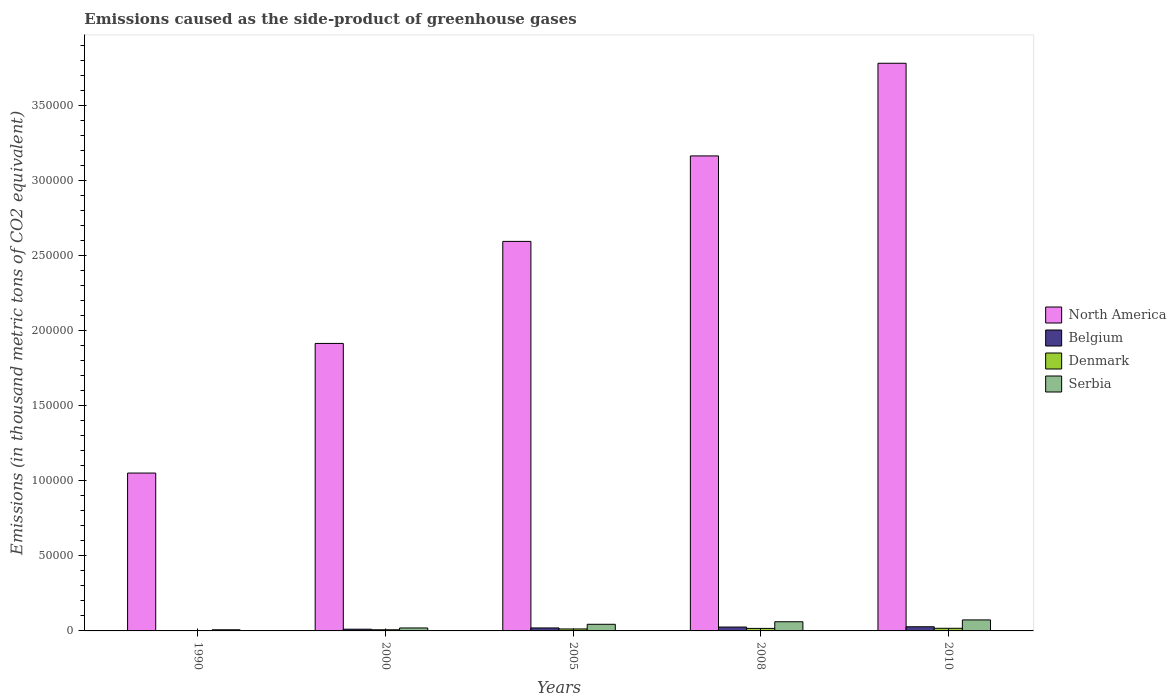How many different coloured bars are there?
Your answer should be very brief. 4. How many bars are there on the 1st tick from the left?
Keep it short and to the point. 4. How many bars are there on the 4th tick from the right?
Make the answer very short. 4. What is the emissions caused as the side-product of greenhouse gases in North America in 2005?
Make the answer very short. 2.60e+05. Across all years, what is the maximum emissions caused as the side-product of greenhouse gases in North America?
Make the answer very short. 3.78e+05. Across all years, what is the minimum emissions caused as the side-product of greenhouse gases in Denmark?
Your response must be concise. 88.4. In which year was the emissions caused as the side-product of greenhouse gases in Serbia maximum?
Provide a succinct answer. 2010. What is the total emissions caused as the side-product of greenhouse gases in Denmark in the graph?
Ensure brevity in your answer.  5592.4. What is the difference between the emissions caused as the side-product of greenhouse gases in Serbia in 1990 and that in 2000?
Offer a terse response. -1205.7. What is the difference between the emissions caused as the side-product of greenhouse gases in Belgium in 2000 and the emissions caused as the side-product of greenhouse gases in Denmark in 2010?
Provide a short and direct response. -595.4. What is the average emissions caused as the side-product of greenhouse gases in Belgium per year?
Ensure brevity in your answer.  1726.34. In the year 2008, what is the difference between the emissions caused as the side-product of greenhouse gases in North America and emissions caused as the side-product of greenhouse gases in Serbia?
Keep it short and to the point. 3.10e+05. In how many years, is the emissions caused as the side-product of greenhouse gases in Belgium greater than 380000 thousand metric tons?
Provide a succinct answer. 0. What is the ratio of the emissions caused as the side-product of greenhouse gases in Serbia in 2005 to that in 2008?
Give a very brief answer. 0.72. Is the emissions caused as the side-product of greenhouse gases in North America in 1990 less than that in 2010?
Provide a short and direct response. Yes. What is the difference between the highest and the second highest emissions caused as the side-product of greenhouse gases in North America?
Keep it short and to the point. 6.17e+04. What is the difference between the highest and the lowest emissions caused as the side-product of greenhouse gases in Denmark?
Provide a short and direct response. 1661.6. In how many years, is the emissions caused as the side-product of greenhouse gases in Serbia greater than the average emissions caused as the side-product of greenhouse gases in Serbia taken over all years?
Ensure brevity in your answer.  3. Is it the case that in every year, the sum of the emissions caused as the side-product of greenhouse gases in North America and emissions caused as the side-product of greenhouse gases in Denmark is greater than the sum of emissions caused as the side-product of greenhouse gases in Serbia and emissions caused as the side-product of greenhouse gases in Belgium?
Ensure brevity in your answer.  Yes. Is it the case that in every year, the sum of the emissions caused as the side-product of greenhouse gases in Belgium and emissions caused as the side-product of greenhouse gases in Serbia is greater than the emissions caused as the side-product of greenhouse gases in Denmark?
Ensure brevity in your answer.  Yes. Are the values on the major ticks of Y-axis written in scientific E-notation?
Your answer should be very brief. No. Where does the legend appear in the graph?
Offer a terse response. Center right. How many legend labels are there?
Your response must be concise. 4. How are the legend labels stacked?
Provide a short and direct response. Vertical. What is the title of the graph?
Offer a terse response. Emissions caused as the side-product of greenhouse gases. What is the label or title of the X-axis?
Offer a very short reply. Years. What is the label or title of the Y-axis?
Ensure brevity in your answer.  Emissions (in thousand metric tons of CO2 equivalent). What is the Emissions (in thousand metric tons of CO2 equivalent) in North America in 1990?
Provide a short and direct response. 1.05e+05. What is the Emissions (in thousand metric tons of CO2 equivalent) of Belgium in 1990?
Provide a succinct answer. 141.9. What is the Emissions (in thousand metric tons of CO2 equivalent) in Denmark in 1990?
Keep it short and to the point. 88.4. What is the Emissions (in thousand metric tons of CO2 equivalent) of Serbia in 1990?
Give a very brief answer. 762.4. What is the Emissions (in thousand metric tons of CO2 equivalent) of North America in 2000?
Offer a very short reply. 1.92e+05. What is the Emissions (in thousand metric tons of CO2 equivalent) in Belgium in 2000?
Provide a short and direct response. 1154.6. What is the Emissions (in thousand metric tons of CO2 equivalent) in Denmark in 2000?
Provide a short and direct response. 767. What is the Emissions (in thousand metric tons of CO2 equivalent) of Serbia in 2000?
Provide a succinct answer. 1968.1. What is the Emissions (in thousand metric tons of CO2 equivalent) of North America in 2005?
Offer a very short reply. 2.60e+05. What is the Emissions (in thousand metric tons of CO2 equivalent) in Belgium in 2005?
Give a very brief answer. 1981.2. What is the Emissions (in thousand metric tons of CO2 equivalent) in Denmark in 2005?
Give a very brief answer. 1302.5. What is the Emissions (in thousand metric tons of CO2 equivalent) in Serbia in 2005?
Your answer should be compact. 4422.8. What is the Emissions (in thousand metric tons of CO2 equivalent) of North America in 2008?
Your answer should be very brief. 3.17e+05. What is the Emissions (in thousand metric tons of CO2 equivalent) in Belgium in 2008?
Your answer should be very brief. 2578. What is the Emissions (in thousand metric tons of CO2 equivalent) of Denmark in 2008?
Offer a very short reply. 1684.5. What is the Emissions (in thousand metric tons of CO2 equivalent) in Serbia in 2008?
Provide a short and direct response. 6111.3. What is the Emissions (in thousand metric tons of CO2 equivalent) in North America in 2010?
Offer a very short reply. 3.78e+05. What is the Emissions (in thousand metric tons of CO2 equivalent) of Belgium in 2010?
Provide a succinct answer. 2776. What is the Emissions (in thousand metric tons of CO2 equivalent) of Denmark in 2010?
Offer a terse response. 1750. What is the Emissions (in thousand metric tons of CO2 equivalent) in Serbia in 2010?
Offer a very short reply. 7338. Across all years, what is the maximum Emissions (in thousand metric tons of CO2 equivalent) in North America?
Your answer should be very brief. 3.78e+05. Across all years, what is the maximum Emissions (in thousand metric tons of CO2 equivalent) in Belgium?
Offer a terse response. 2776. Across all years, what is the maximum Emissions (in thousand metric tons of CO2 equivalent) in Denmark?
Offer a terse response. 1750. Across all years, what is the maximum Emissions (in thousand metric tons of CO2 equivalent) in Serbia?
Your response must be concise. 7338. Across all years, what is the minimum Emissions (in thousand metric tons of CO2 equivalent) in North America?
Ensure brevity in your answer.  1.05e+05. Across all years, what is the minimum Emissions (in thousand metric tons of CO2 equivalent) of Belgium?
Give a very brief answer. 141.9. Across all years, what is the minimum Emissions (in thousand metric tons of CO2 equivalent) of Denmark?
Your answer should be compact. 88.4. Across all years, what is the minimum Emissions (in thousand metric tons of CO2 equivalent) of Serbia?
Keep it short and to the point. 762.4. What is the total Emissions (in thousand metric tons of CO2 equivalent) of North America in the graph?
Your answer should be compact. 1.25e+06. What is the total Emissions (in thousand metric tons of CO2 equivalent) of Belgium in the graph?
Your answer should be very brief. 8631.7. What is the total Emissions (in thousand metric tons of CO2 equivalent) in Denmark in the graph?
Give a very brief answer. 5592.4. What is the total Emissions (in thousand metric tons of CO2 equivalent) of Serbia in the graph?
Your response must be concise. 2.06e+04. What is the difference between the Emissions (in thousand metric tons of CO2 equivalent) in North America in 1990 and that in 2000?
Offer a terse response. -8.64e+04. What is the difference between the Emissions (in thousand metric tons of CO2 equivalent) of Belgium in 1990 and that in 2000?
Offer a terse response. -1012.7. What is the difference between the Emissions (in thousand metric tons of CO2 equivalent) in Denmark in 1990 and that in 2000?
Provide a succinct answer. -678.6. What is the difference between the Emissions (in thousand metric tons of CO2 equivalent) of Serbia in 1990 and that in 2000?
Provide a short and direct response. -1205.7. What is the difference between the Emissions (in thousand metric tons of CO2 equivalent) in North America in 1990 and that in 2005?
Keep it short and to the point. -1.54e+05. What is the difference between the Emissions (in thousand metric tons of CO2 equivalent) of Belgium in 1990 and that in 2005?
Provide a short and direct response. -1839.3. What is the difference between the Emissions (in thousand metric tons of CO2 equivalent) in Denmark in 1990 and that in 2005?
Provide a short and direct response. -1214.1. What is the difference between the Emissions (in thousand metric tons of CO2 equivalent) in Serbia in 1990 and that in 2005?
Your answer should be very brief. -3660.4. What is the difference between the Emissions (in thousand metric tons of CO2 equivalent) in North America in 1990 and that in 2008?
Offer a terse response. -2.11e+05. What is the difference between the Emissions (in thousand metric tons of CO2 equivalent) in Belgium in 1990 and that in 2008?
Keep it short and to the point. -2436.1. What is the difference between the Emissions (in thousand metric tons of CO2 equivalent) of Denmark in 1990 and that in 2008?
Offer a terse response. -1596.1. What is the difference between the Emissions (in thousand metric tons of CO2 equivalent) in Serbia in 1990 and that in 2008?
Ensure brevity in your answer.  -5348.9. What is the difference between the Emissions (in thousand metric tons of CO2 equivalent) in North America in 1990 and that in 2010?
Make the answer very short. -2.73e+05. What is the difference between the Emissions (in thousand metric tons of CO2 equivalent) in Belgium in 1990 and that in 2010?
Your response must be concise. -2634.1. What is the difference between the Emissions (in thousand metric tons of CO2 equivalent) of Denmark in 1990 and that in 2010?
Offer a terse response. -1661.6. What is the difference between the Emissions (in thousand metric tons of CO2 equivalent) in Serbia in 1990 and that in 2010?
Provide a short and direct response. -6575.6. What is the difference between the Emissions (in thousand metric tons of CO2 equivalent) of North America in 2000 and that in 2005?
Your answer should be very brief. -6.80e+04. What is the difference between the Emissions (in thousand metric tons of CO2 equivalent) of Belgium in 2000 and that in 2005?
Offer a terse response. -826.6. What is the difference between the Emissions (in thousand metric tons of CO2 equivalent) in Denmark in 2000 and that in 2005?
Offer a very short reply. -535.5. What is the difference between the Emissions (in thousand metric tons of CO2 equivalent) in Serbia in 2000 and that in 2005?
Your answer should be very brief. -2454.7. What is the difference between the Emissions (in thousand metric tons of CO2 equivalent) in North America in 2000 and that in 2008?
Offer a terse response. -1.25e+05. What is the difference between the Emissions (in thousand metric tons of CO2 equivalent) of Belgium in 2000 and that in 2008?
Your response must be concise. -1423.4. What is the difference between the Emissions (in thousand metric tons of CO2 equivalent) in Denmark in 2000 and that in 2008?
Your answer should be very brief. -917.5. What is the difference between the Emissions (in thousand metric tons of CO2 equivalent) of Serbia in 2000 and that in 2008?
Give a very brief answer. -4143.2. What is the difference between the Emissions (in thousand metric tons of CO2 equivalent) of North America in 2000 and that in 2010?
Offer a terse response. -1.87e+05. What is the difference between the Emissions (in thousand metric tons of CO2 equivalent) of Belgium in 2000 and that in 2010?
Give a very brief answer. -1621.4. What is the difference between the Emissions (in thousand metric tons of CO2 equivalent) of Denmark in 2000 and that in 2010?
Offer a terse response. -983. What is the difference between the Emissions (in thousand metric tons of CO2 equivalent) of Serbia in 2000 and that in 2010?
Provide a succinct answer. -5369.9. What is the difference between the Emissions (in thousand metric tons of CO2 equivalent) in North America in 2005 and that in 2008?
Your answer should be compact. -5.70e+04. What is the difference between the Emissions (in thousand metric tons of CO2 equivalent) in Belgium in 2005 and that in 2008?
Keep it short and to the point. -596.8. What is the difference between the Emissions (in thousand metric tons of CO2 equivalent) in Denmark in 2005 and that in 2008?
Offer a very short reply. -382. What is the difference between the Emissions (in thousand metric tons of CO2 equivalent) of Serbia in 2005 and that in 2008?
Give a very brief answer. -1688.5. What is the difference between the Emissions (in thousand metric tons of CO2 equivalent) in North America in 2005 and that in 2010?
Provide a short and direct response. -1.19e+05. What is the difference between the Emissions (in thousand metric tons of CO2 equivalent) of Belgium in 2005 and that in 2010?
Your answer should be very brief. -794.8. What is the difference between the Emissions (in thousand metric tons of CO2 equivalent) in Denmark in 2005 and that in 2010?
Your response must be concise. -447.5. What is the difference between the Emissions (in thousand metric tons of CO2 equivalent) in Serbia in 2005 and that in 2010?
Provide a short and direct response. -2915.2. What is the difference between the Emissions (in thousand metric tons of CO2 equivalent) of North America in 2008 and that in 2010?
Make the answer very short. -6.17e+04. What is the difference between the Emissions (in thousand metric tons of CO2 equivalent) of Belgium in 2008 and that in 2010?
Your answer should be very brief. -198. What is the difference between the Emissions (in thousand metric tons of CO2 equivalent) of Denmark in 2008 and that in 2010?
Keep it short and to the point. -65.5. What is the difference between the Emissions (in thousand metric tons of CO2 equivalent) of Serbia in 2008 and that in 2010?
Your response must be concise. -1226.7. What is the difference between the Emissions (in thousand metric tons of CO2 equivalent) of North America in 1990 and the Emissions (in thousand metric tons of CO2 equivalent) of Belgium in 2000?
Keep it short and to the point. 1.04e+05. What is the difference between the Emissions (in thousand metric tons of CO2 equivalent) in North America in 1990 and the Emissions (in thousand metric tons of CO2 equivalent) in Denmark in 2000?
Your answer should be compact. 1.04e+05. What is the difference between the Emissions (in thousand metric tons of CO2 equivalent) of North America in 1990 and the Emissions (in thousand metric tons of CO2 equivalent) of Serbia in 2000?
Provide a short and direct response. 1.03e+05. What is the difference between the Emissions (in thousand metric tons of CO2 equivalent) of Belgium in 1990 and the Emissions (in thousand metric tons of CO2 equivalent) of Denmark in 2000?
Ensure brevity in your answer.  -625.1. What is the difference between the Emissions (in thousand metric tons of CO2 equivalent) of Belgium in 1990 and the Emissions (in thousand metric tons of CO2 equivalent) of Serbia in 2000?
Make the answer very short. -1826.2. What is the difference between the Emissions (in thousand metric tons of CO2 equivalent) in Denmark in 1990 and the Emissions (in thousand metric tons of CO2 equivalent) in Serbia in 2000?
Provide a short and direct response. -1879.7. What is the difference between the Emissions (in thousand metric tons of CO2 equivalent) in North America in 1990 and the Emissions (in thousand metric tons of CO2 equivalent) in Belgium in 2005?
Offer a terse response. 1.03e+05. What is the difference between the Emissions (in thousand metric tons of CO2 equivalent) of North America in 1990 and the Emissions (in thousand metric tons of CO2 equivalent) of Denmark in 2005?
Offer a terse response. 1.04e+05. What is the difference between the Emissions (in thousand metric tons of CO2 equivalent) in North America in 1990 and the Emissions (in thousand metric tons of CO2 equivalent) in Serbia in 2005?
Make the answer very short. 1.01e+05. What is the difference between the Emissions (in thousand metric tons of CO2 equivalent) in Belgium in 1990 and the Emissions (in thousand metric tons of CO2 equivalent) in Denmark in 2005?
Provide a succinct answer. -1160.6. What is the difference between the Emissions (in thousand metric tons of CO2 equivalent) in Belgium in 1990 and the Emissions (in thousand metric tons of CO2 equivalent) in Serbia in 2005?
Provide a short and direct response. -4280.9. What is the difference between the Emissions (in thousand metric tons of CO2 equivalent) in Denmark in 1990 and the Emissions (in thousand metric tons of CO2 equivalent) in Serbia in 2005?
Offer a terse response. -4334.4. What is the difference between the Emissions (in thousand metric tons of CO2 equivalent) in North America in 1990 and the Emissions (in thousand metric tons of CO2 equivalent) in Belgium in 2008?
Your answer should be very brief. 1.03e+05. What is the difference between the Emissions (in thousand metric tons of CO2 equivalent) of North America in 1990 and the Emissions (in thousand metric tons of CO2 equivalent) of Denmark in 2008?
Provide a succinct answer. 1.04e+05. What is the difference between the Emissions (in thousand metric tons of CO2 equivalent) in North America in 1990 and the Emissions (in thousand metric tons of CO2 equivalent) in Serbia in 2008?
Ensure brevity in your answer.  9.91e+04. What is the difference between the Emissions (in thousand metric tons of CO2 equivalent) of Belgium in 1990 and the Emissions (in thousand metric tons of CO2 equivalent) of Denmark in 2008?
Offer a terse response. -1542.6. What is the difference between the Emissions (in thousand metric tons of CO2 equivalent) in Belgium in 1990 and the Emissions (in thousand metric tons of CO2 equivalent) in Serbia in 2008?
Make the answer very short. -5969.4. What is the difference between the Emissions (in thousand metric tons of CO2 equivalent) of Denmark in 1990 and the Emissions (in thousand metric tons of CO2 equivalent) of Serbia in 2008?
Provide a succinct answer. -6022.9. What is the difference between the Emissions (in thousand metric tons of CO2 equivalent) of North America in 1990 and the Emissions (in thousand metric tons of CO2 equivalent) of Belgium in 2010?
Make the answer very short. 1.02e+05. What is the difference between the Emissions (in thousand metric tons of CO2 equivalent) in North America in 1990 and the Emissions (in thousand metric tons of CO2 equivalent) in Denmark in 2010?
Your answer should be very brief. 1.03e+05. What is the difference between the Emissions (in thousand metric tons of CO2 equivalent) in North America in 1990 and the Emissions (in thousand metric tons of CO2 equivalent) in Serbia in 2010?
Your answer should be very brief. 9.79e+04. What is the difference between the Emissions (in thousand metric tons of CO2 equivalent) in Belgium in 1990 and the Emissions (in thousand metric tons of CO2 equivalent) in Denmark in 2010?
Keep it short and to the point. -1608.1. What is the difference between the Emissions (in thousand metric tons of CO2 equivalent) in Belgium in 1990 and the Emissions (in thousand metric tons of CO2 equivalent) in Serbia in 2010?
Provide a short and direct response. -7196.1. What is the difference between the Emissions (in thousand metric tons of CO2 equivalent) in Denmark in 1990 and the Emissions (in thousand metric tons of CO2 equivalent) in Serbia in 2010?
Ensure brevity in your answer.  -7249.6. What is the difference between the Emissions (in thousand metric tons of CO2 equivalent) of North America in 2000 and the Emissions (in thousand metric tons of CO2 equivalent) of Belgium in 2005?
Your response must be concise. 1.90e+05. What is the difference between the Emissions (in thousand metric tons of CO2 equivalent) in North America in 2000 and the Emissions (in thousand metric tons of CO2 equivalent) in Denmark in 2005?
Offer a terse response. 1.90e+05. What is the difference between the Emissions (in thousand metric tons of CO2 equivalent) in North America in 2000 and the Emissions (in thousand metric tons of CO2 equivalent) in Serbia in 2005?
Ensure brevity in your answer.  1.87e+05. What is the difference between the Emissions (in thousand metric tons of CO2 equivalent) of Belgium in 2000 and the Emissions (in thousand metric tons of CO2 equivalent) of Denmark in 2005?
Ensure brevity in your answer.  -147.9. What is the difference between the Emissions (in thousand metric tons of CO2 equivalent) of Belgium in 2000 and the Emissions (in thousand metric tons of CO2 equivalent) of Serbia in 2005?
Offer a terse response. -3268.2. What is the difference between the Emissions (in thousand metric tons of CO2 equivalent) in Denmark in 2000 and the Emissions (in thousand metric tons of CO2 equivalent) in Serbia in 2005?
Your answer should be compact. -3655.8. What is the difference between the Emissions (in thousand metric tons of CO2 equivalent) in North America in 2000 and the Emissions (in thousand metric tons of CO2 equivalent) in Belgium in 2008?
Provide a succinct answer. 1.89e+05. What is the difference between the Emissions (in thousand metric tons of CO2 equivalent) of North America in 2000 and the Emissions (in thousand metric tons of CO2 equivalent) of Denmark in 2008?
Offer a very short reply. 1.90e+05. What is the difference between the Emissions (in thousand metric tons of CO2 equivalent) of North America in 2000 and the Emissions (in thousand metric tons of CO2 equivalent) of Serbia in 2008?
Provide a short and direct response. 1.85e+05. What is the difference between the Emissions (in thousand metric tons of CO2 equivalent) in Belgium in 2000 and the Emissions (in thousand metric tons of CO2 equivalent) in Denmark in 2008?
Make the answer very short. -529.9. What is the difference between the Emissions (in thousand metric tons of CO2 equivalent) in Belgium in 2000 and the Emissions (in thousand metric tons of CO2 equivalent) in Serbia in 2008?
Give a very brief answer. -4956.7. What is the difference between the Emissions (in thousand metric tons of CO2 equivalent) in Denmark in 2000 and the Emissions (in thousand metric tons of CO2 equivalent) in Serbia in 2008?
Provide a short and direct response. -5344.3. What is the difference between the Emissions (in thousand metric tons of CO2 equivalent) in North America in 2000 and the Emissions (in thousand metric tons of CO2 equivalent) in Belgium in 2010?
Offer a very short reply. 1.89e+05. What is the difference between the Emissions (in thousand metric tons of CO2 equivalent) of North America in 2000 and the Emissions (in thousand metric tons of CO2 equivalent) of Denmark in 2010?
Give a very brief answer. 1.90e+05. What is the difference between the Emissions (in thousand metric tons of CO2 equivalent) of North America in 2000 and the Emissions (in thousand metric tons of CO2 equivalent) of Serbia in 2010?
Provide a succinct answer. 1.84e+05. What is the difference between the Emissions (in thousand metric tons of CO2 equivalent) in Belgium in 2000 and the Emissions (in thousand metric tons of CO2 equivalent) in Denmark in 2010?
Ensure brevity in your answer.  -595.4. What is the difference between the Emissions (in thousand metric tons of CO2 equivalent) of Belgium in 2000 and the Emissions (in thousand metric tons of CO2 equivalent) of Serbia in 2010?
Ensure brevity in your answer.  -6183.4. What is the difference between the Emissions (in thousand metric tons of CO2 equivalent) of Denmark in 2000 and the Emissions (in thousand metric tons of CO2 equivalent) of Serbia in 2010?
Provide a short and direct response. -6571. What is the difference between the Emissions (in thousand metric tons of CO2 equivalent) of North America in 2005 and the Emissions (in thousand metric tons of CO2 equivalent) of Belgium in 2008?
Ensure brevity in your answer.  2.57e+05. What is the difference between the Emissions (in thousand metric tons of CO2 equivalent) in North America in 2005 and the Emissions (in thousand metric tons of CO2 equivalent) in Denmark in 2008?
Ensure brevity in your answer.  2.58e+05. What is the difference between the Emissions (in thousand metric tons of CO2 equivalent) of North America in 2005 and the Emissions (in thousand metric tons of CO2 equivalent) of Serbia in 2008?
Your response must be concise. 2.53e+05. What is the difference between the Emissions (in thousand metric tons of CO2 equivalent) of Belgium in 2005 and the Emissions (in thousand metric tons of CO2 equivalent) of Denmark in 2008?
Provide a short and direct response. 296.7. What is the difference between the Emissions (in thousand metric tons of CO2 equivalent) in Belgium in 2005 and the Emissions (in thousand metric tons of CO2 equivalent) in Serbia in 2008?
Give a very brief answer. -4130.1. What is the difference between the Emissions (in thousand metric tons of CO2 equivalent) in Denmark in 2005 and the Emissions (in thousand metric tons of CO2 equivalent) in Serbia in 2008?
Your answer should be very brief. -4808.8. What is the difference between the Emissions (in thousand metric tons of CO2 equivalent) in North America in 2005 and the Emissions (in thousand metric tons of CO2 equivalent) in Belgium in 2010?
Your answer should be compact. 2.57e+05. What is the difference between the Emissions (in thousand metric tons of CO2 equivalent) of North America in 2005 and the Emissions (in thousand metric tons of CO2 equivalent) of Denmark in 2010?
Keep it short and to the point. 2.58e+05. What is the difference between the Emissions (in thousand metric tons of CO2 equivalent) in North America in 2005 and the Emissions (in thousand metric tons of CO2 equivalent) in Serbia in 2010?
Keep it short and to the point. 2.52e+05. What is the difference between the Emissions (in thousand metric tons of CO2 equivalent) of Belgium in 2005 and the Emissions (in thousand metric tons of CO2 equivalent) of Denmark in 2010?
Give a very brief answer. 231.2. What is the difference between the Emissions (in thousand metric tons of CO2 equivalent) of Belgium in 2005 and the Emissions (in thousand metric tons of CO2 equivalent) of Serbia in 2010?
Give a very brief answer. -5356.8. What is the difference between the Emissions (in thousand metric tons of CO2 equivalent) in Denmark in 2005 and the Emissions (in thousand metric tons of CO2 equivalent) in Serbia in 2010?
Keep it short and to the point. -6035.5. What is the difference between the Emissions (in thousand metric tons of CO2 equivalent) in North America in 2008 and the Emissions (in thousand metric tons of CO2 equivalent) in Belgium in 2010?
Give a very brief answer. 3.14e+05. What is the difference between the Emissions (in thousand metric tons of CO2 equivalent) of North America in 2008 and the Emissions (in thousand metric tons of CO2 equivalent) of Denmark in 2010?
Offer a very short reply. 3.15e+05. What is the difference between the Emissions (in thousand metric tons of CO2 equivalent) of North America in 2008 and the Emissions (in thousand metric tons of CO2 equivalent) of Serbia in 2010?
Make the answer very short. 3.09e+05. What is the difference between the Emissions (in thousand metric tons of CO2 equivalent) in Belgium in 2008 and the Emissions (in thousand metric tons of CO2 equivalent) in Denmark in 2010?
Provide a short and direct response. 828. What is the difference between the Emissions (in thousand metric tons of CO2 equivalent) of Belgium in 2008 and the Emissions (in thousand metric tons of CO2 equivalent) of Serbia in 2010?
Your response must be concise. -4760. What is the difference between the Emissions (in thousand metric tons of CO2 equivalent) in Denmark in 2008 and the Emissions (in thousand metric tons of CO2 equivalent) in Serbia in 2010?
Keep it short and to the point. -5653.5. What is the average Emissions (in thousand metric tons of CO2 equivalent) in North America per year?
Ensure brevity in your answer.  2.50e+05. What is the average Emissions (in thousand metric tons of CO2 equivalent) of Belgium per year?
Ensure brevity in your answer.  1726.34. What is the average Emissions (in thousand metric tons of CO2 equivalent) in Denmark per year?
Provide a succinct answer. 1118.48. What is the average Emissions (in thousand metric tons of CO2 equivalent) in Serbia per year?
Provide a short and direct response. 4120.52. In the year 1990, what is the difference between the Emissions (in thousand metric tons of CO2 equivalent) in North America and Emissions (in thousand metric tons of CO2 equivalent) in Belgium?
Ensure brevity in your answer.  1.05e+05. In the year 1990, what is the difference between the Emissions (in thousand metric tons of CO2 equivalent) in North America and Emissions (in thousand metric tons of CO2 equivalent) in Denmark?
Ensure brevity in your answer.  1.05e+05. In the year 1990, what is the difference between the Emissions (in thousand metric tons of CO2 equivalent) of North America and Emissions (in thousand metric tons of CO2 equivalent) of Serbia?
Provide a succinct answer. 1.04e+05. In the year 1990, what is the difference between the Emissions (in thousand metric tons of CO2 equivalent) of Belgium and Emissions (in thousand metric tons of CO2 equivalent) of Denmark?
Ensure brevity in your answer.  53.5. In the year 1990, what is the difference between the Emissions (in thousand metric tons of CO2 equivalent) in Belgium and Emissions (in thousand metric tons of CO2 equivalent) in Serbia?
Your answer should be very brief. -620.5. In the year 1990, what is the difference between the Emissions (in thousand metric tons of CO2 equivalent) of Denmark and Emissions (in thousand metric tons of CO2 equivalent) of Serbia?
Offer a terse response. -674. In the year 2000, what is the difference between the Emissions (in thousand metric tons of CO2 equivalent) in North America and Emissions (in thousand metric tons of CO2 equivalent) in Belgium?
Provide a short and direct response. 1.90e+05. In the year 2000, what is the difference between the Emissions (in thousand metric tons of CO2 equivalent) in North America and Emissions (in thousand metric tons of CO2 equivalent) in Denmark?
Offer a very short reply. 1.91e+05. In the year 2000, what is the difference between the Emissions (in thousand metric tons of CO2 equivalent) in North America and Emissions (in thousand metric tons of CO2 equivalent) in Serbia?
Offer a very short reply. 1.90e+05. In the year 2000, what is the difference between the Emissions (in thousand metric tons of CO2 equivalent) of Belgium and Emissions (in thousand metric tons of CO2 equivalent) of Denmark?
Your answer should be compact. 387.6. In the year 2000, what is the difference between the Emissions (in thousand metric tons of CO2 equivalent) in Belgium and Emissions (in thousand metric tons of CO2 equivalent) in Serbia?
Keep it short and to the point. -813.5. In the year 2000, what is the difference between the Emissions (in thousand metric tons of CO2 equivalent) of Denmark and Emissions (in thousand metric tons of CO2 equivalent) of Serbia?
Offer a terse response. -1201.1. In the year 2005, what is the difference between the Emissions (in thousand metric tons of CO2 equivalent) in North America and Emissions (in thousand metric tons of CO2 equivalent) in Belgium?
Offer a very short reply. 2.58e+05. In the year 2005, what is the difference between the Emissions (in thousand metric tons of CO2 equivalent) in North America and Emissions (in thousand metric tons of CO2 equivalent) in Denmark?
Provide a succinct answer. 2.58e+05. In the year 2005, what is the difference between the Emissions (in thousand metric tons of CO2 equivalent) of North America and Emissions (in thousand metric tons of CO2 equivalent) of Serbia?
Your answer should be compact. 2.55e+05. In the year 2005, what is the difference between the Emissions (in thousand metric tons of CO2 equivalent) in Belgium and Emissions (in thousand metric tons of CO2 equivalent) in Denmark?
Your answer should be compact. 678.7. In the year 2005, what is the difference between the Emissions (in thousand metric tons of CO2 equivalent) in Belgium and Emissions (in thousand metric tons of CO2 equivalent) in Serbia?
Provide a succinct answer. -2441.6. In the year 2005, what is the difference between the Emissions (in thousand metric tons of CO2 equivalent) in Denmark and Emissions (in thousand metric tons of CO2 equivalent) in Serbia?
Provide a succinct answer. -3120.3. In the year 2008, what is the difference between the Emissions (in thousand metric tons of CO2 equivalent) of North America and Emissions (in thousand metric tons of CO2 equivalent) of Belgium?
Your answer should be very brief. 3.14e+05. In the year 2008, what is the difference between the Emissions (in thousand metric tons of CO2 equivalent) in North America and Emissions (in thousand metric tons of CO2 equivalent) in Denmark?
Give a very brief answer. 3.15e+05. In the year 2008, what is the difference between the Emissions (in thousand metric tons of CO2 equivalent) in North America and Emissions (in thousand metric tons of CO2 equivalent) in Serbia?
Give a very brief answer. 3.10e+05. In the year 2008, what is the difference between the Emissions (in thousand metric tons of CO2 equivalent) of Belgium and Emissions (in thousand metric tons of CO2 equivalent) of Denmark?
Your answer should be very brief. 893.5. In the year 2008, what is the difference between the Emissions (in thousand metric tons of CO2 equivalent) in Belgium and Emissions (in thousand metric tons of CO2 equivalent) in Serbia?
Make the answer very short. -3533.3. In the year 2008, what is the difference between the Emissions (in thousand metric tons of CO2 equivalent) in Denmark and Emissions (in thousand metric tons of CO2 equivalent) in Serbia?
Provide a short and direct response. -4426.8. In the year 2010, what is the difference between the Emissions (in thousand metric tons of CO2 equivalent) in North America and Emissions (in thousand metric tons of CO2 equivalent) in Belgium?
Ensure brevity in your answer.  3.76e+05. In the year 2010, what is the difference between the Emissions (in thousand metric tons of CO2 equivalent) in North America and Emissions (in thousand metric tons of CO2 equivalent) in Denmark?
Give a very brief answer. 3.77e+05. In the year 2010, what is the difference between the Emissions (in thousand metric tons of CO2 equivalent) in North America and Emissions (in thousand metric tons of CO2 equivalent) in Serbia?
Keep it short and to the point. 3.71e+05. In the year 2010, what is the difference between the Emissions (in thousand metric tons of CO2 equivalent) in Belgium and Emissions (in thousand metric tons of CO2 equivalent) in Denmark?
Ensure brevity in your answer.  1026. In the year 2010, what is the difference between the Emissions (in thousand metric tons of CO2 equivalent) in Belgium and Emissions (in thousand metric tons of CO2 equivalent) in Serbia?
Offer a very short reply. -4562. In the year 2010, what is the difference between the Emissions (in thousand metric tons of CO2 equivalent) of Denmark and Emissions (in thousand metric tons of CO2 equivalent) of Serbia?
Your answer should be very brief. -5588. What is the ratio of the Emissions (in thousand metric tons of CO2 equivalent) in North America in 1990 to that in 2000?
Make the answer very short. 0.55. What is the ratio of the Emissions (in thousand metric tons of CO2 equivalent) of Belgium in 1990 to that in 2000?
Your response must be concise. 0.12. What is the ratio of the Emissions (in thousand metric tons of CO2 equivalent) in Denmark in 1990 to that in 2000?
Keep it short and to the point. 0.12. What is the ratio of the Emissions (in thousand metric tons of CO2 equivalent) of Serbia in 1990 to that in 2000?
Your answer should be compact. 0.39. What is the ratio of the Emissions (in thousand metric tons of CO2 equivalent) of North America in 1990 to that in 2005?
Make the answer very short. 0.41. What is the ratio of the Emissions (in thousand metric tons of CO2 equivalent) of Belgium in 1990 to that in 2005?
Ensure brevity in your answer.  0.07. What is the ratio of the Emissions (in thousand metric tons of CO2 equivalent) of Denmark in 1990 to that in 2005?
Your answer should be very brief. 0.07. What is the ratio of the Emissions (in thousand metric tons of CO2 equivalent) of Serbia in 1990 to that in 2005?
Offer a terse response. 0.17. What is the ratio of the Emissions (in thousand metric tons of CO2 equivalent) of North America in 1990 to that in 2008?
Offer a terse response. 0.33. What is the ratio of the Emissions (in thousand metric tons of CO2 equivalent) of Belgium in 1990 to that in 2008?
Offer a very short reply. 0.06. What is the ratio of the Emissions (in thousand metric tons of CO2 equivalent) in Denmark in 1990 to that in 2008?
Provide a succinct answer. 0.05. What is the ratio of the Emissions (in thousand metric tons of CO2 equivalent) in Serbia in 1990 to that in 2008?
Your response must be concise. 0.12. What is the ratio of the Emissions (in thousand metric tons of CO2 equivalent) of North America in 1990 to that in 2010?
Keep it short and to the point. 0.28. What is the ratio of the Emissions (in thousand metric tons of CO2 equivalent) of Belgium in 1990 to that in 2010?
Ensure brevity in your answer.  0.05. What is the ratio of the Emissions (in thousand metric tons of CO2 equivalent) in Denmark in 1990 to that in 2010?
Your response must be concise. 0.05. What is the ratio of the Emissions (in thousand metric tons of CO2 equivalent) of Serbia in 1990 to that in 2010?
Ensure brevity in your answer.  0.1. What is the ratio of the Emissions (in thousand metric tons of CO2 equivalent) in North America in 2000 to that in 2005?
Your answer should be compact. 0.74. What is the ratio of the Emissions (in thousand metric tons of CO2 equivalent) in Belgium in 2000 to that in 2005?
Offer a very short reply. 0.58. What is the ratio of the Emissions (in thousand metric tons of CO2 equivalent) in Denmark in 2000 to that in 2005?
Your answer should be compact. 0.59. What is the ratio of the Emissions (in thousand metric tons of CO2 equivalent) in Serbia in 2000 to that in 2005?
Ensure brevity in your answer.  0.45. What is the ratio of the Emissions (in thousand metric tons of CO2 equivalent) in North America in 2000 to that in 2008?
Your answer should be compact. 0.61. What is the ratio of the Emissions (in thousand metric tons of CO2 equivalent) in Belgium in 2000 to that in 2008?
Offer a very short reply. 0.45. What is the ratio of the Emissions (in thousand metric tons of CO2 equivalent) in Denmark in 2000 to that in 2008?
Offer a terse response. 0.46. What is the ratio of the Emissions (in thousand metric tons of CO2 equivalent) in Serbia in 2000 to that in 2008?
Provide a succinct answer. 0.32. What is the ratio of the Emissions (in thousand metric tons of CO2 equivalent) in North America in 2000 to that in 2010?
Provide a short and direct response. 0.51. What is the ratio of the Emissions (in thousand metric tons of CO2 equivalent) of Belgium in 2000 to that in 2010?
Give a very brief answer. 0.42. What is the ratio of the Emissions (in thousand metric tons of CO2 equivalent) in Denmark in 2000 to that in 2010?
Provide a short and direct response. 0.44. What is the ratio of the Emissions (in thousand metric tons of CO2 equivalent) in Serbia in 2000 to that in 2010?
Offer a very short reply. 0.27. What is the ratio of the Emissions (in thousand metric tons of CO2 equivalent) of North America in 2005 to that in 2008?
Your answer should be very brief. 0.82. What is the ratio of the Emissions (in thousand metric tons of CO2 equivalent) in Belgium in 2005 to that in 2008?
Provide a succinct answer. 0.77. What is the ratio of the Emissions (in thousand metric tons of CO2 equivalent) in Denmark in 2005 to that in 2008?
Give a very brief answer. 0.77. What is the ratio of the Emissions (in thousand metric tons of CO2 equivalent) of Serbia in 2005 to that in 2008?
Offer a very short reply. 0.72. What is the ratio of the Emissions (in thousand metric tons of CO2 equivalent) of North America in 2005 to that in 2010?
Give a very brief answer. 0.69. What is the ratio of the Emissions (in thousand metric tons of CO2 equivalent) of Belgium in 2005 to that in 2010?
Offer a terse response. 0.71. What is the ratio of the Emissions (in thousand metric tons of CO2 equivalent) of Denmark in 2005 to that in 2010?
Your answer should be compact. 0.74. What is the ratio of the Emissions (in thousand metric tons of CO2 equivalent) in Serbia in 2005 to that in 2010?
Your answer should be compact. 0.6. What is the ratio of the Emissions (in thousand metric tons of CO2 equivalent) of North America in 2008 to that in 2010?
Keep it short and to the point. 0.84. What is the ratio of the Emissions (in thousand metric tons of CO2 equivalent) in Belgium in 2008 to that in 2010?
Offer a very short reply. 0.93. What is the ratio of the Emissions (in thousand metric tons of CO2 equivalent) in Denmark in 2008 to that in 2010?
Give a very brief answer. 0.96. What is the ratio of the Emissions (in thousand metric tons of CO2 equivalent) in Serbia in 2008 to that in 2010?
Offer a terse response. 0.83. What is the difference between the highest and the second highest Emissions (in thousand metric tons of CO2 equivalent) in North America?
Ensure brevity in your answer.  6.17e+04. What is the difference between the highest and the second highest Emissions (in thousand metric tons of CO2 equivalent) in Belgium?
Keep it short and to the point. 198. What is the difference between the highest and the second highest Emissions (in thousand metric tons of CO2 equivalent) in Denmark?
Give a very brief answer. 65.5. What is the difference between the highest and the second highest Emissions (in thousand metric tons of CO2 equivalent) in Serbia?
Provide a succinct answer. 1226.7. What is the difference between the highest and the lowest Emissions (in thousand metric tons of CO2 equivalent) in North America?
Give a very brief answer. 2.73e+05. What is the difference between the highest and the lowest Emissions (in thousand metric tons of CO2 equivalent) in Belgium?
Make the answer very short. 2634.1. What is the difference between the highest and the lowest Emissions (in thousand metric tons of CO2 equivalent) of Denmark?
Make the answer very short. 1661.6. What is the difference between the highest and the lowest Emissions (in thousand metric tons of CO2 equivalent) in Serbia?
Provide a succinct answer. 6575.6. 